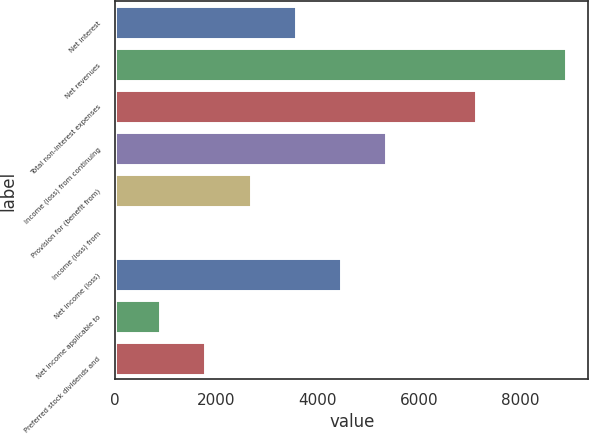Convert chart. <chart><loc_0><loc_0><loc_500><loc_500><bar_chart><fcel>Net interest<fcel>Net revenues<fcel>Total non-interest expenses<fcel>Income (loss) from continuing<fcel>Provision for (benefit from)<fcel>Income (loss) from<fcel>Net income (loss)<fcel>Net income applicable to<fcel>Preferred stock dividends and<nl><fcel>3567.6<fcel>8907<fcel>7127.2<fcel>5347.4<fcel>2677.7<fcel>8<fcel>4457.5<fcel>897.9<fcel>1787.8<nl></chart> 